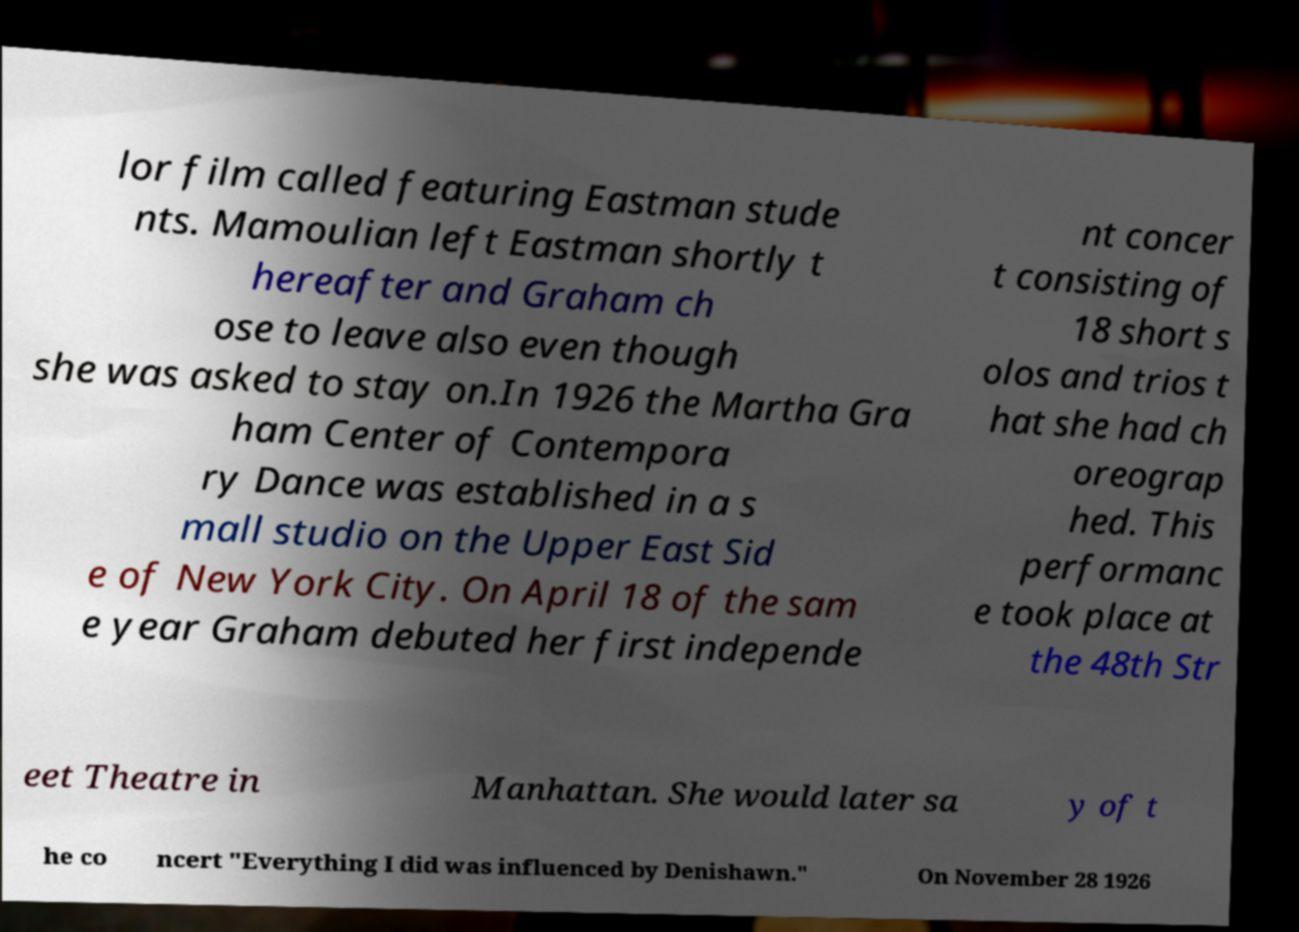Please identify and transcribe the text found in this image. lor film called featuring Eastman stude nts. Mamoulian left Eastman shortly t hereafter and Graham ch ose to leave also even though she was asked to stay on.In 1926 the Martha Gra ham Center of Contempora ry Dance was established in a s mall studio on the Upper East Sid e of New York City. On April 18 of the sam e year Graham debuted her first independe nt concer t consisting of 18 short s olos and trios t hat she had ch oreograp hed. This performanc e took place at the 48th Str eet Theatre in Manhattan. She would later sa y of t he co ncert "Everything I did was influenced by Denishawn." On November 28 1926 